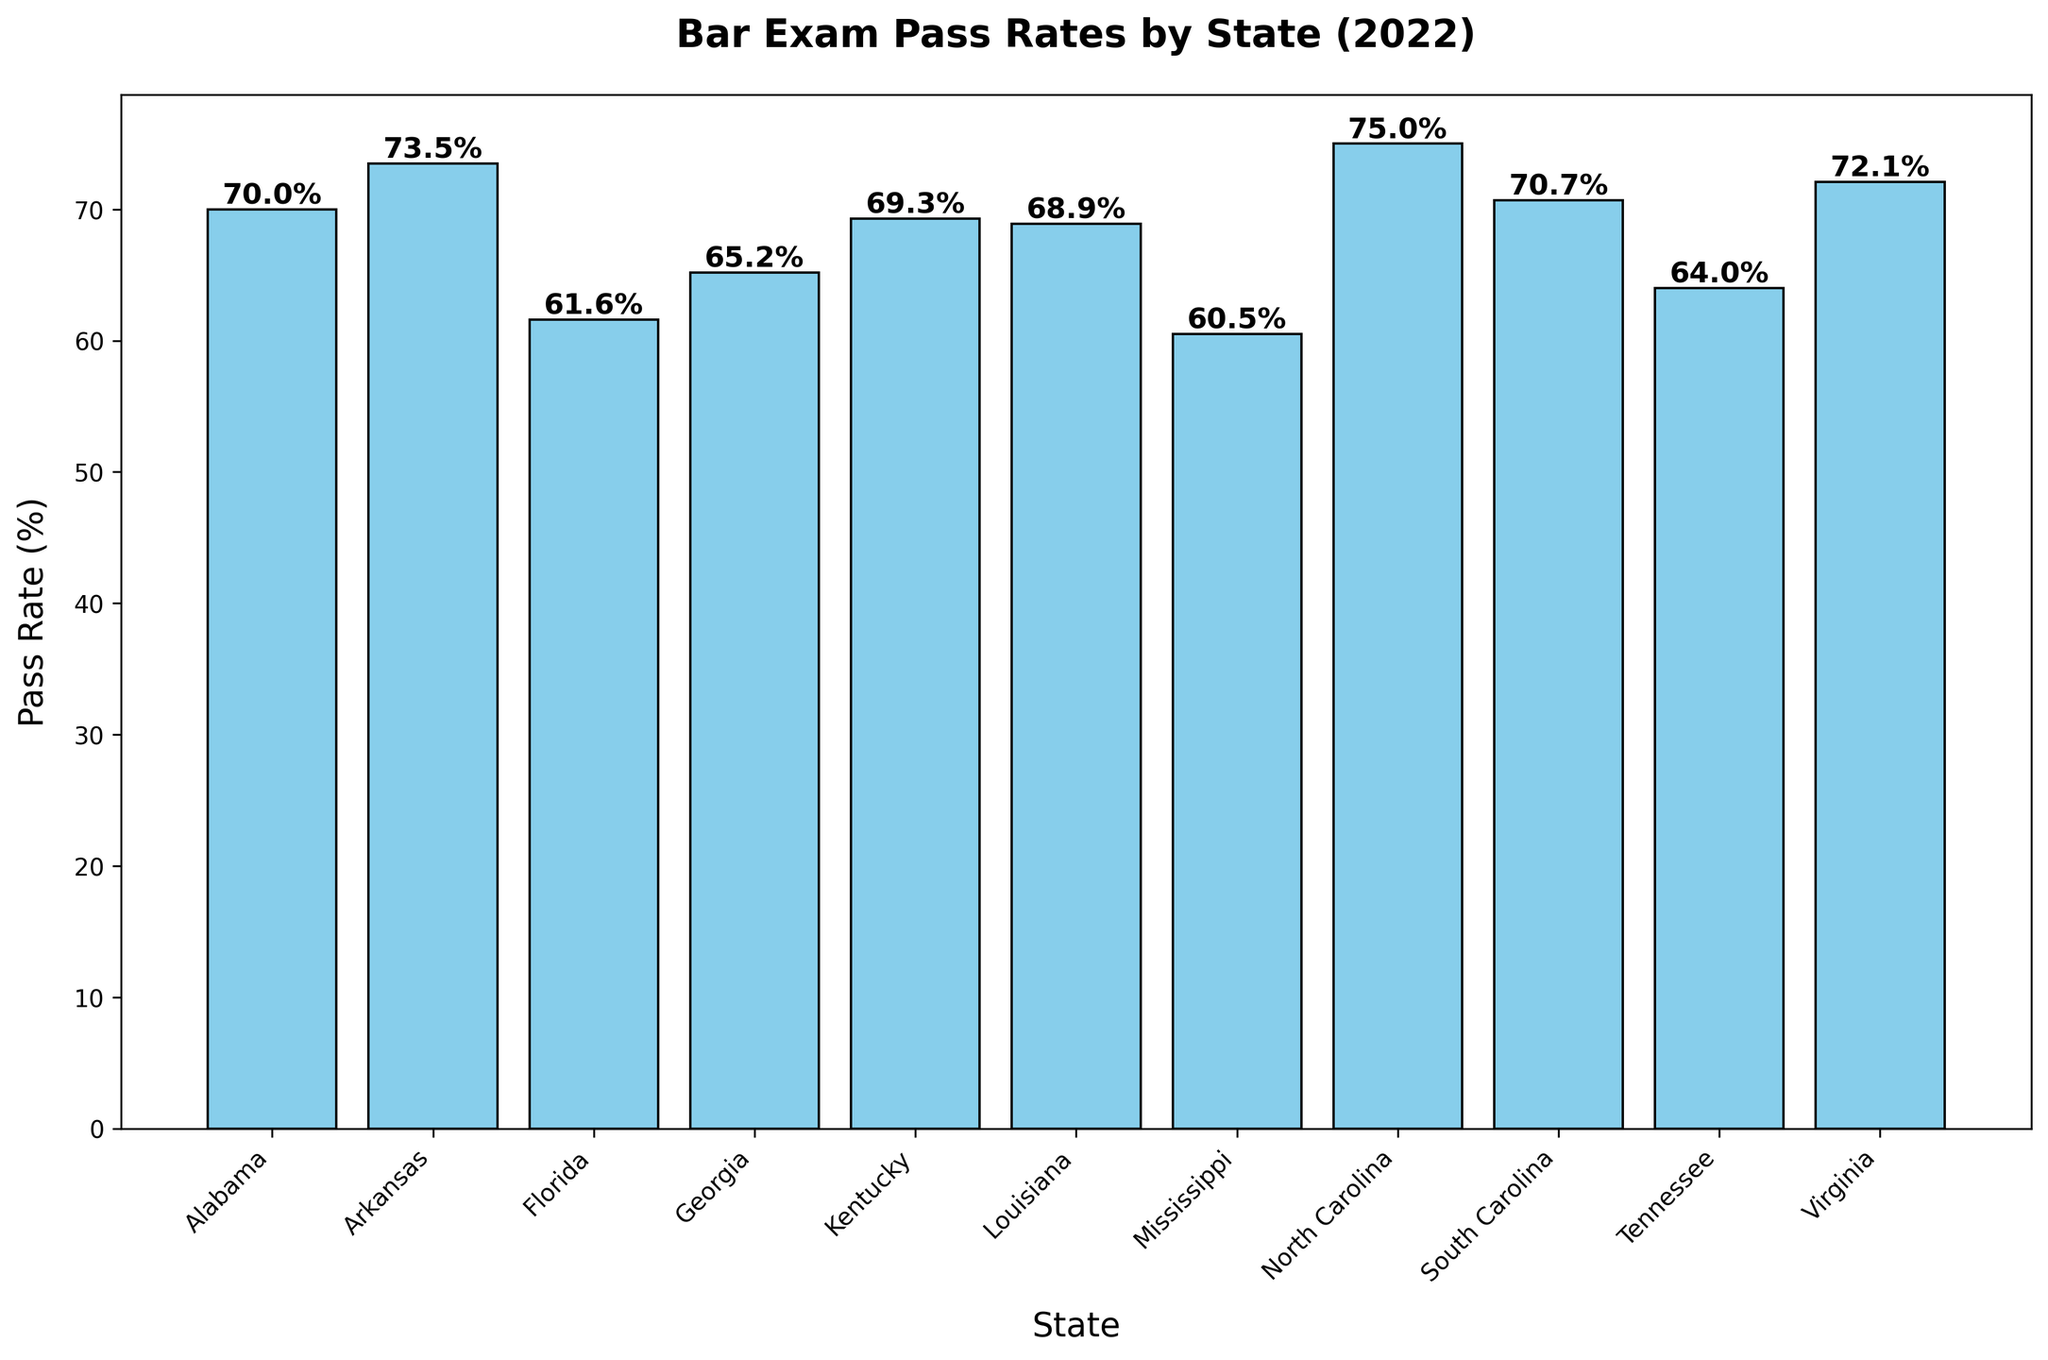Which state has the highest bar exam pass rate? The state with the highest bar exam pass rate is North Carolina. This can be observed by identifying the tallest bar in the chart, which represents a pass rate of 75.0%.
Answer: North Carolina Which state has the lowest bar exam pass rate? The state with the lowest bar exam pass rate is Mississippi. This can be determined by noting the shortest bar in the chart, which corresponds to a pass rate of 60.5%.
Answer: Mississippi How does the bar exam pass rate in Georgia compare to that in Tennessee? To compare the bar exam pass rates, look at the bars for Georgia and Tennessee. Georgia's pass rate is 65.2%, while Tennessee's pass rate is 64.0%. Georgia's pass rate is higher than Tennessee's by 1.2 percentage points.
Answer: Georgia's rate is higher by 1.2% What is the difference between the highest and lowest bar exam pass rates among these states? The highest pass rate is in North Carolina (75.0%) and the lowest is in Mississippi (60.5%). The difference is calculated as 75.0% - 60.5% = 14.5 percentage points.
Answer: 14.5 percentage points Calculate the average bar exam pass rate among all the states listed. To find the average pass rate, sum up all the pass rates and divide by the number of states. The sum of the pass rates is 70.0% + 73.5% + 61.6% + 65.2% + 69.3% + 68.9% + 60.5% + 75.0% + 70.7% + 64.0% + 72.1% = 751.8%. There are 11 states, so the average is 751.8% / 11 ≈ 68.35%.
Answer: 68.35% Identify all states with a bar exam pass rate below the overall average. The overall average pass rate is approximately 68.35%. The states with pass rates below this average are Florida (61.6%), Georgia (65.2%), Mississippi (60.5%), Tennessee (64.0%).
Answer: Florida, Georgia, Mississippi, Tennessee Rank the states in descending order of their bar exam pass rates. To rank the states, order their pass rates from highest to lowest: North Carolina (75.0%), Arkansas (73.5%), Virginia (72.1%), South Carolina (70.7%), Alabama (70.0%), Kentucky (69.3%), Louisiana (68.9%), Georgia (65.2%), Tennessee (64.0%), Florida (61.6%), Mississippi (60.5%).
Answer: North Carolina, Arkansas, Virginia, South Carolina, Alabama, Kentucky, Louisiana, Georgia, Tennessee, Florida, Mississippi Which states have a pass rate within 2 percentage points of South Carolina's pass rate? South Carolina's pass rate is 70.7%. States within 2 percentage points are Alabama (70.0%) and Kentucky (69.3%); both are within ±2 points of South Carolina's rate.
Answer: Alabama, Kentucky Determine the median bar exam pass rate and identify the corresponding state(s). To find the median, list the pass rates in ascending order: 60.5%, 61.6%, 64.0%, 65.2%, 68.9%, 69.3%, 70.0%, 70.7%, 72.1%, 73.5%, 75.0%. The median pass rate (middle value) is 69.3%, which corresponds to Kentucky.
Answer: Kentucky 